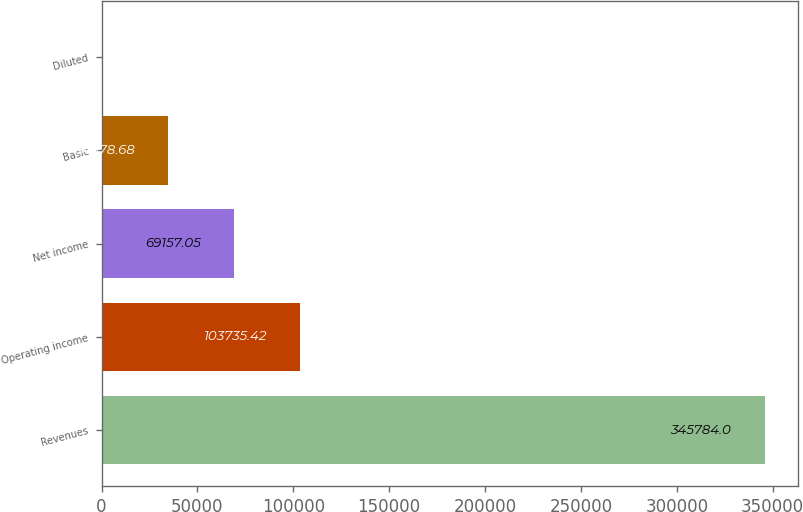Convert chart. <chart><loc_0><loc_0><loc_500><loc_500><bar_chart><fcel>Revenues<fcel>Operating income<fcel>Net income<fcel>Basic<fcel>Diluted<nl><fcel>345784<fcel>103735<fcel>69157.1<fcel>34578.7<fcel>0.31<nl></chart> 